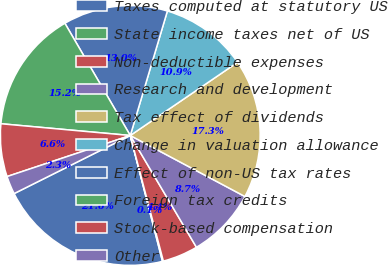Convert chart. <chart><loc_0><loc_0><loc_500><loc_500><pie_chart><fcel>Taxes computed at statutory US<fcel>State income taxes net of US<fcel>Non-deductible expenses<fcel>Research and development<fcel>Tax effect of dividends<fcel>Change in valuation allowance<fcel>Effect of non-US tax rates<fcel>Foreign tax credits<fcel>Stock-based compensation<fcel>Other<nl><fcel>21.61%<fcel>0.11%<fcel>4.41%<fcel>8.71%<fcel>17.31%<fcel>10.86%<fcel>13.01%<fcel>15.16%<fcel>6.56%<fcel>2.26%<nl></chart> 